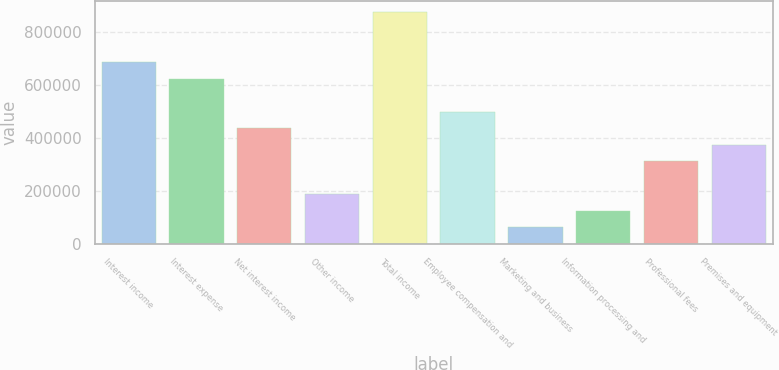<chart> <loc_0><loc_0><loc_500><loc_500><bar_chart><fcel>Interest income<fcel>Interest expense<fcel>Net interest income<fcel>Other income<fcel>Total income<fcel>Employee compensation and<fcel>Marketing and business<fcel>Information processing and<fcel>Professional fees<fcel>Premises and equipment<nl><fcel>688250<fcel>625694<fcel>438026<fcel>187801<fcel>875918<fcel>500582<fcel>62689.1<fcel>125245<fcel>312914<fcel>375470<nl></chart> 